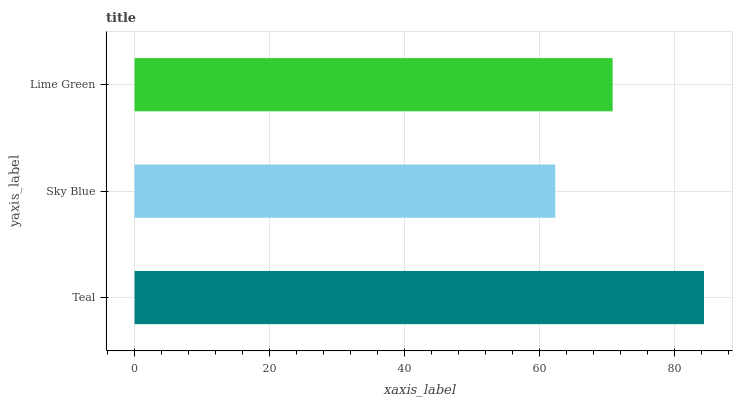Is Sky Blue the minimum?
Answer yes or no. Yes. Is Teal the maximum?
Answer yes or no. Yes. Is Lime Green the minimum?
Answer yes or no. No. Is Lime Green the maximum?
Answer yes or no. No. Is Lime Green greater than Sky Blue?
Answer yes or no. Yes. Is Sky Blue less than Lime Green?
Answer yes or no. Yes. Is Sky Blue greater than Lime Green?
Answer yes or no. No. Is Lime Green less than Sky Blue?
Answer yes or no. No. Is Lime Green the high median?
Answer yes or no. Yes. Is Lime Green the low median?
Answer yes or no. Yes. Is Sky Blue the high median?
Answer yes or no. No. Is Teal the low median?
Answer yes or no. No. 